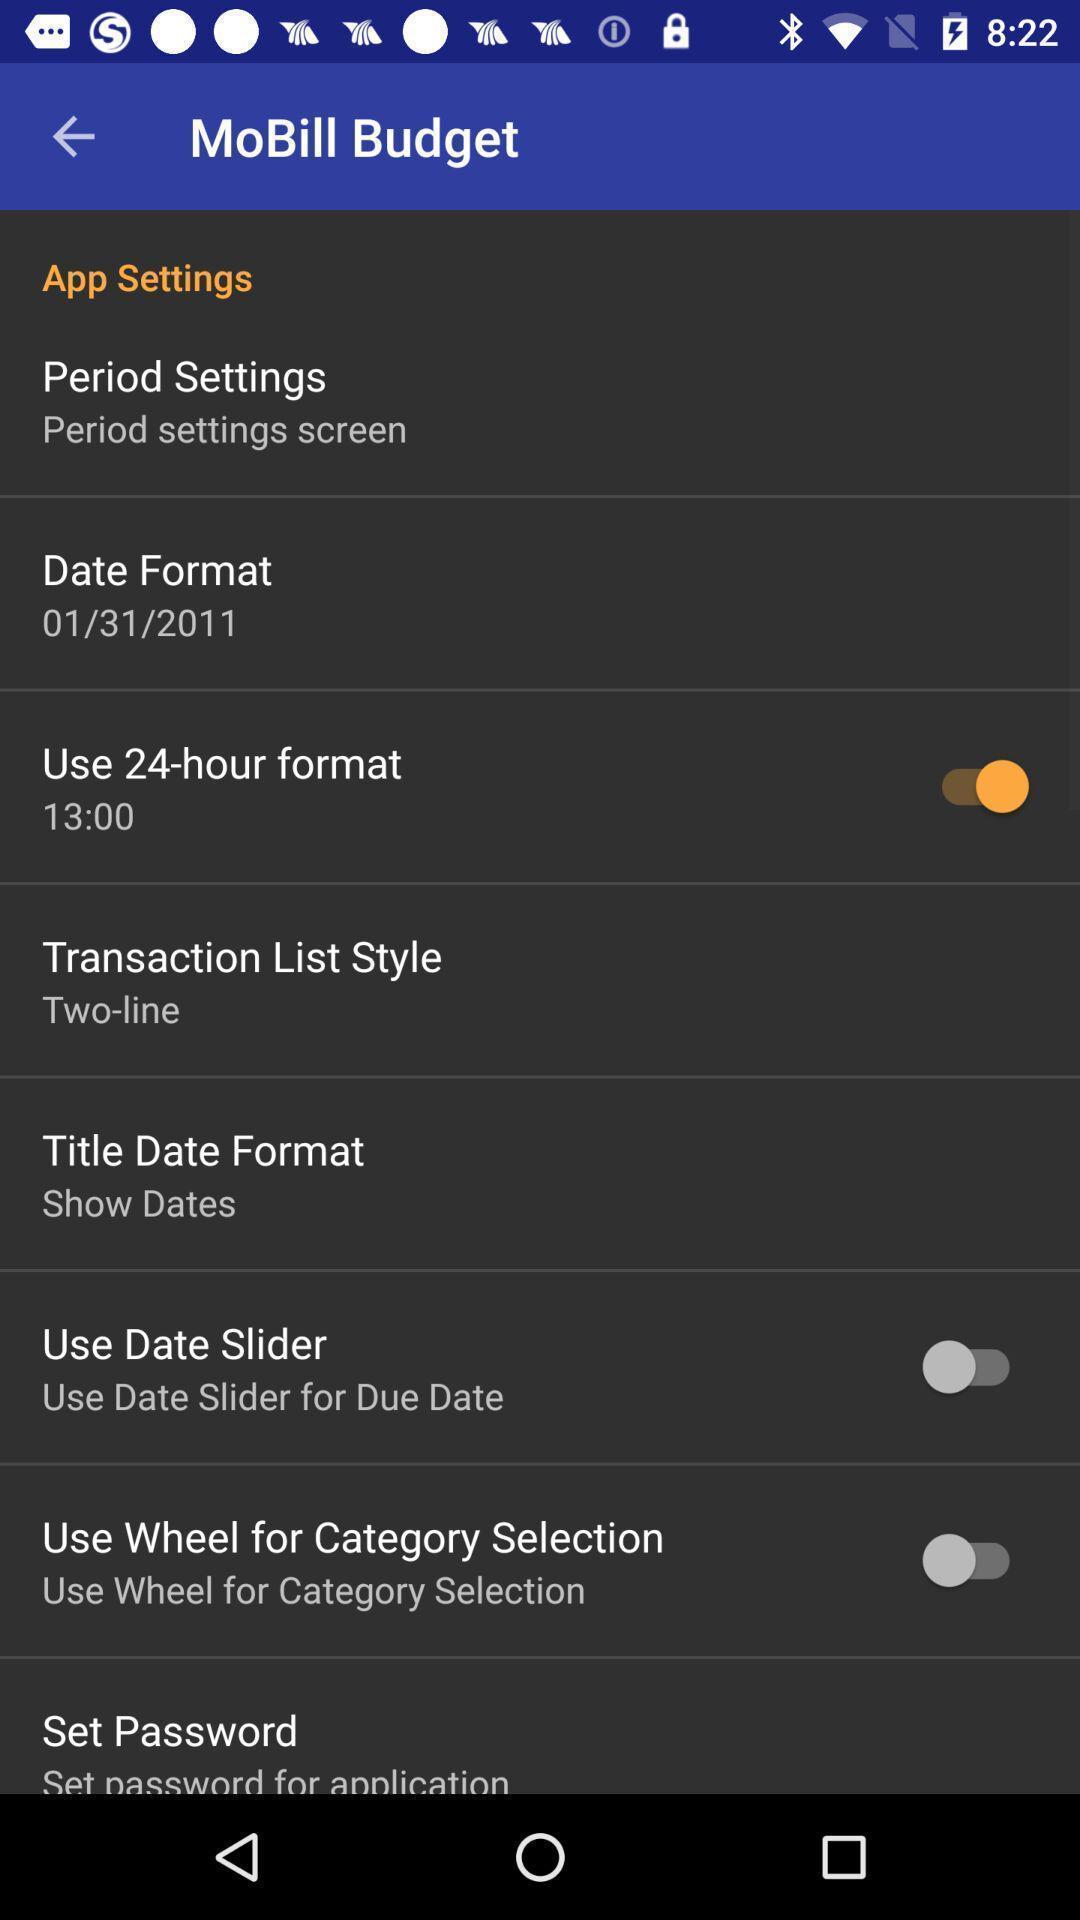Describe this image in words. Screen displaying list of app settings. 